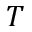<formula> <loc_0><loc_0><loc_500><loc_500>T</formula> 